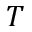<formula> <loc_0><loc_0><loc_500><loc_500>T</formula> 